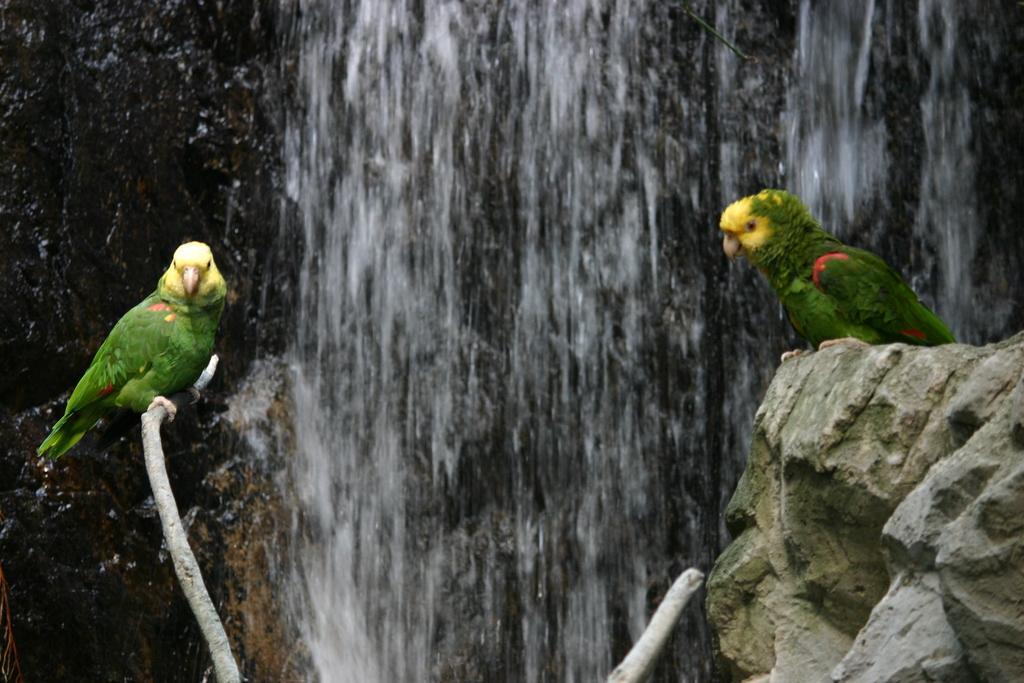Could you give a brief overview of what you see in this image? In this picture we can see two birds and a rock, in the background we can see waterfall. 